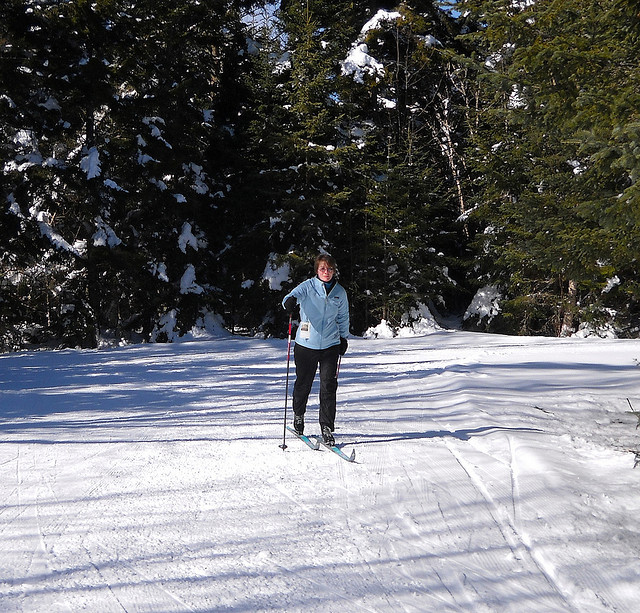Can you describe the environment where this activity is taking place? The activity is happening in a serene, snow-covered forest with tall coniferous trees. There is ample snow on the ground, and it appears to be a crisp, sunny day, which is ideal for outdoor winter sports like cross-country skiing. Is this type of environment important for cross-country skiing? Yes, cross-country skiing commonly takes place in snowy environments, as flat or rolling landscapes with a thick snow cover are needed to provide the right terrain for gliding and striding on skis. 